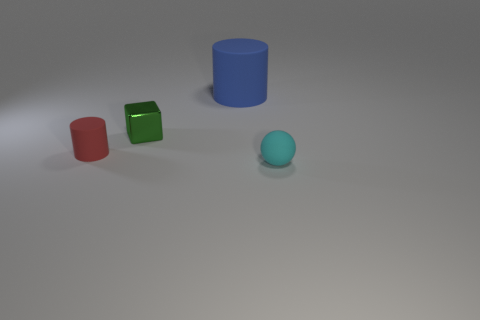Is there any other thing that has the same size as the blue thing?
Offer a very short reply. No. Is there anything else that is the same shape as the small green thing?
Make the answer very short. No. How many shiny things are large blue cylinders or tiny cyan objects?
Offer a very short reply. 0. Is the number of small cyan things that are in front of the small matte ball less than the number of red shiny blocks?
Provide a succinct answer. No. There is a rubber object that is in front of the tiny matte object behind the small matte object to the right of the large blue cylinder; what is its shape?
Provide a short and direct response. Sphere. Are there more metal blocks than yellow cylinders?
Your answer should be compact. Yes. How many other things are made of the same material as the large cylinder?
Your answer should be compact. 2. How many things are big gray metal cylinders or things to the left of the small green metallic object?
Provide a short and direct response. 1. Is the number of tiny blue matte blocks less than the number of large blue rubber cylinders?
Make the answer very short. Yes. There is a thing right of the matte cylinder that is to the right of the small rubber object to the left of the tiny cyan object; what color is it?
Provide a succinct answer. Cyan. 